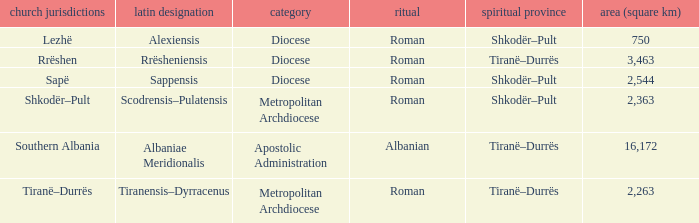In which ecclesiastical province can a type diocese be found that has the latin designation "alexiensis"? Shkodër–Pult. 